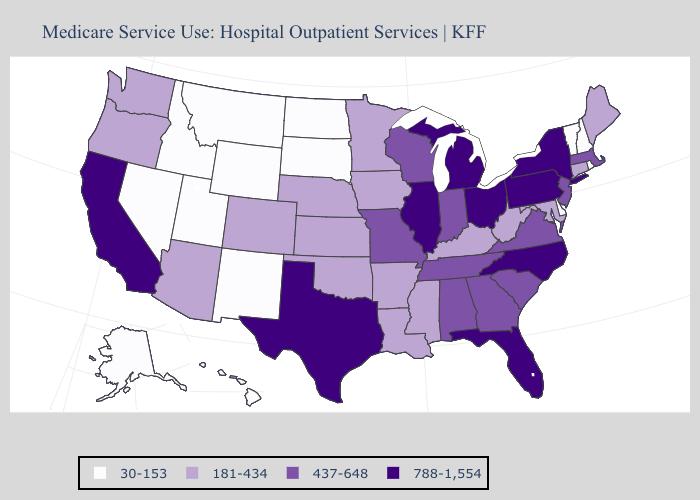What is the value of Idaho?
Quick response, please. 30-153. Name the states that have a value in the range 181-434?
Answer briefly. Arizona, Arkansas, Colorado, Connecticut, Iowa, Kansas, Kentucky, Louisiana, Maine, Maryland, Minnesota, Mississippi, Nebraska, Oklahoma, Oregon, Washington, West Virginia. What is the lowest value in states that border Florida?
Answer briefly. 437-648. Among the states that border Oregon , does Washington have the lowest value?
Concise answer only. No. What is the highest value in states that border Idaho?
Quick response, please. 181-434. What is the value of Texas?
Write a very short answer. 788-1,554. What is the value of Virginia?
Concise answer only. 437-648. What is the value of New Jersey?
Write a very short answer. 437-648. Name the states that have a value in the range 437-648?
Give a very brief answer. Alabama, Georgia, Indiana, Massachusetts, Missouri, New Jersey, South Carolina, Tennessee, Virginia, Wisconsin. Does Nevada have the same value as Tennessee?
Concise answer only. No. Which states have the lowest value in the USA?
Answer briefly. Alaska, Delaware, Hawaii, Idaho, Montana, Nevada, New Hampshire, New Mexico, North Dakota, Rhode Island, South Dakota, Utah, Vermont, Wyoming. Which states have the highest value in the USA?
Quick response, please. California, Florida, Illinois, Michigan, New York, North Carolina, Ohio, Pennsylvania, Texas. What is the highest value in the USA?
Concise answer only. 788-1,554. What is the lowest value in states that border Texas?
Give a very brief answer. 30-153. What is the value of Colorado?
Concise answer only. 181-434. 